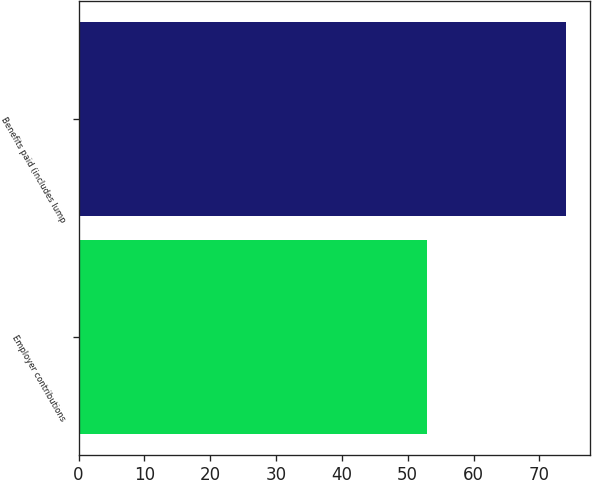Convert chart. <chart><loc_0><loc_0><loc_500><loc_500><bar_chart><fcel>Employer contributions<fcel>Benefits paid (includes lump<nl><fcel>53<fcel>74<nl></chart> 